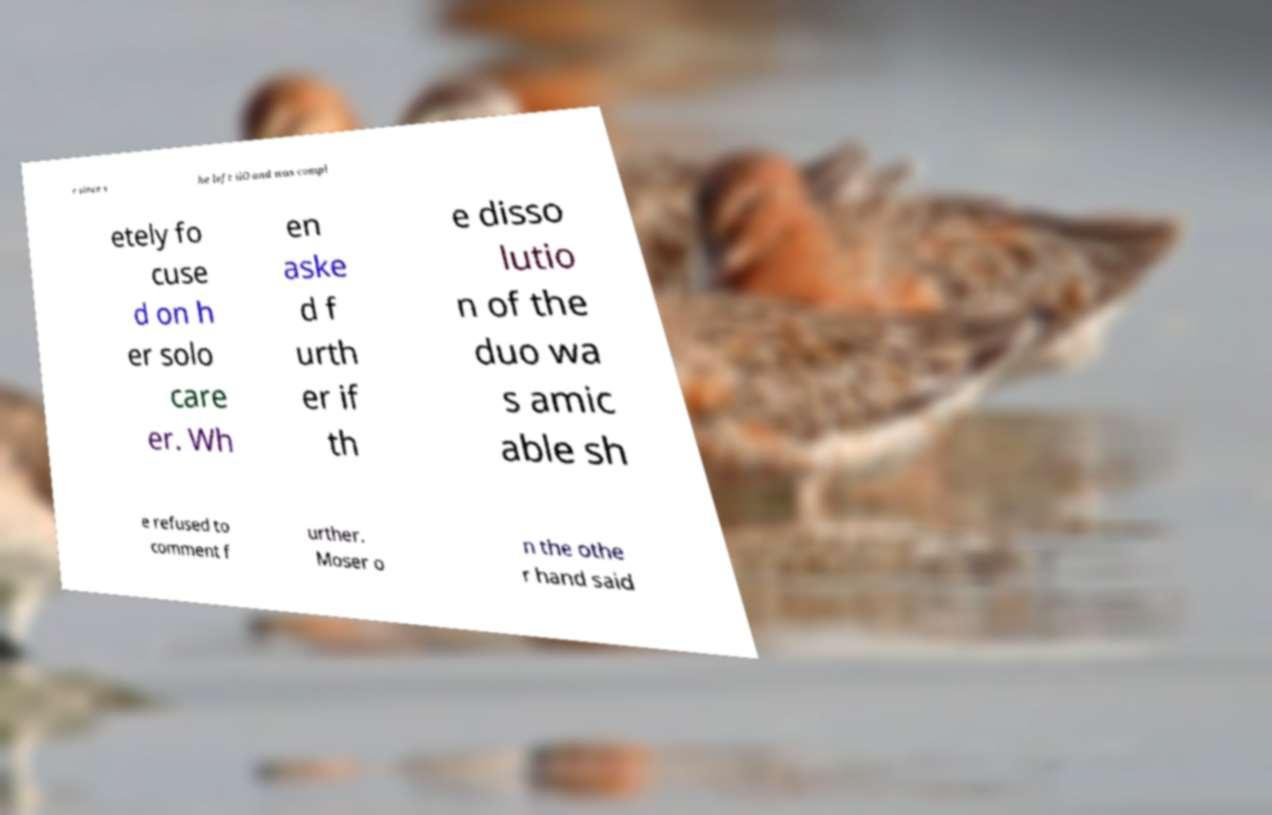Could you assist in decoding the text presented in this image and type it out clearly? r since s he left iiO and was compl etely fo cuse d on h er solo care er. Wh en aske d f urth er if th e disso lutio n of the duo wa s amic able sh e refused to comment f urther. Moser o n the othe r hand said 